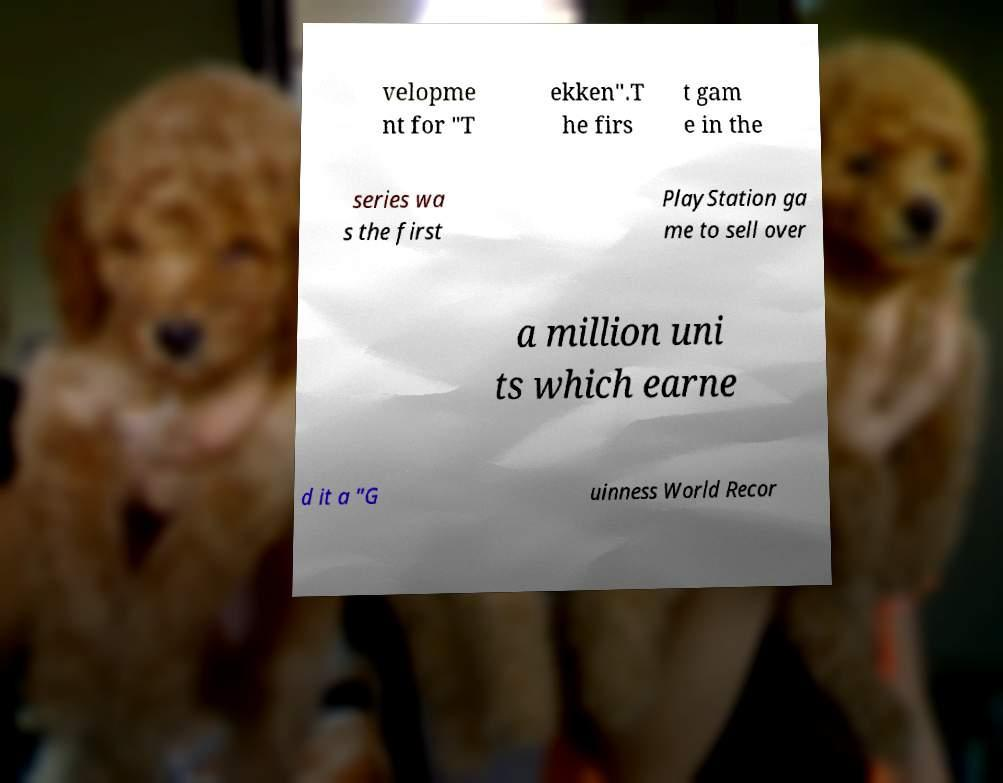I need the written content from this picture converted into text. Can you do that? velopme nt for "T ekken".T he firs t gam e in the series wa s the first PlayStation ga me to sell over a million uni ts which earne d it a "G uinness World Recor 